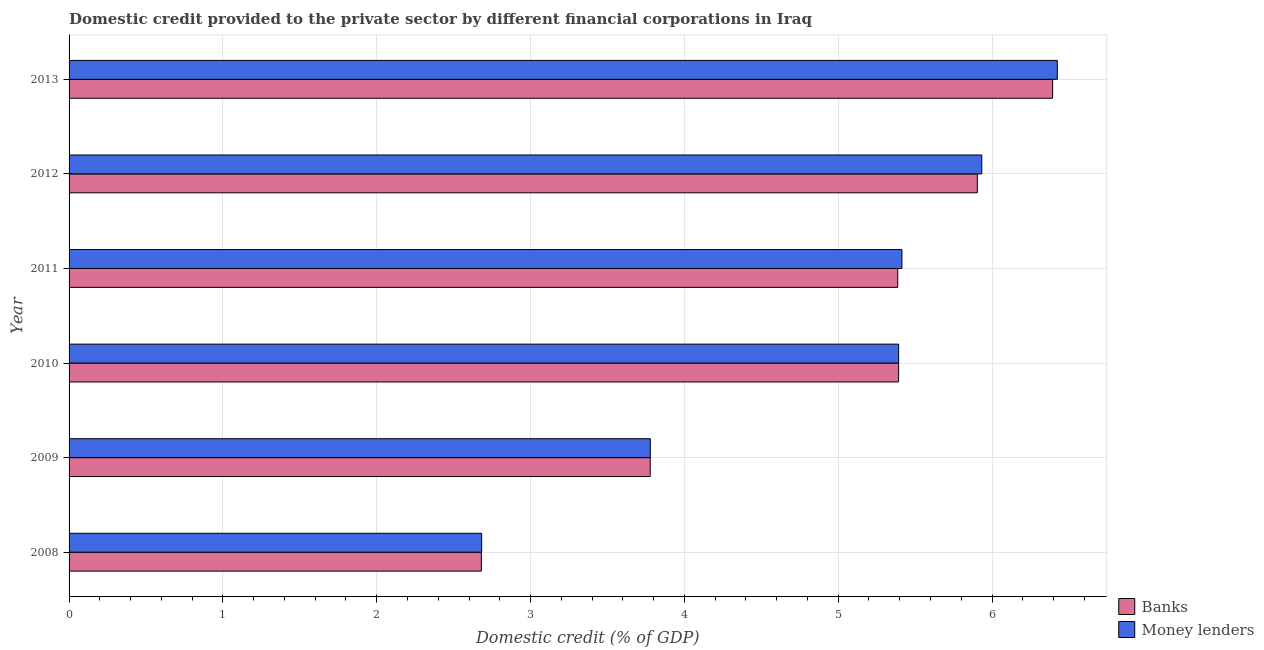How many groups of bars are there?
Make the answer very short. 6. Are the number of bars on each tick of the Y-axis equal?
Provide a succinct answer. Yes. What is the label of the 3rd group of bars from the top?
Your response must be concise. 2011. In how many cases, is the number of bars for a given year not equal to the number of legend labels?
Provide a succinct answer. 0. What is the domestic credit provided by banks in 2013?
Your response must be concise. 6.39. Across all years, what is the maximum domestic credit provided by money lenders?
Your response must be concise. 6.42. Across all years, what is the minimum domestic credit provided by money lenders?
Your answer should be compact. 2.68. What is the total domestic credit provided by banks in the graph?
Offer a terse response. 29.54. What is the difference between the domestic credit provided by banks in 2008 and that in 2011?
Offer a very short reply. -2.71. What is the difference between the domestic credit provided by banks in 2012 and the domestic credit provided by money lenders in 2011?
Provide a succinct answer. 0.49. What is the average domestic credit provided by banks per year?
Offer a very short reply. 4.92. In the year 2012, what is the difference between the domestic credit provided by money lenders and domestic credit provided by banks?
Offer a very short reply. 0.03. In how many years, is the domestic credit provided by money lenders greater than 3.2 %?
Your response must be concise. 5. What is the ratio of the domestic credit provided by money lenders in 2008 to that in 2011?
Keep it short and to the point. 0.49. Is the domestic credit provided by banks in 2008 less than that in 2010?
Offer a terse response. Yes. Is the difference between the domestic credit provided by money lenders in 2010 and 2012 greater than the difference between the domestic credit provided by banks in 2010 and 2012?
Offer a terse response. No. What is the difference between the highest and the second highest domestic credit provided by banks?
Keep it short and to the point. 0.49. What is the difference between the highest and the lowest domestic credit provided by money lenders?
Your answer should be very brief. 3.74. What does the 1st bar from the top in 2010 represents?
Provide a succinct answer. Money lenders. What does the 2nd bar from the bottom in 2010 represents?
Your answer should be compact. Money lenders. How many years are there in the graph?
Your answer should be compact. 6. What is the difference between two consecutive major ticks on the X-axis?
Ensure brevity in your answer.  1. Where does the legend appear in the graph?
Provide a succinct answer. Bottom right. How are the legend labels stacked?
Offer a very short reply. Vertical. What is the title of the graph?
Provide a short and direct response. Domestic credit provided to the private sector by different financial corporations in Iraq. Does "Resident workers" appear as one of the legend labels in the graph?
Your answer should be compact. No. What is the label or title of the X-axis?
Your response must be concise. Domestic credit (% of GDP). What is the label or title of the Y-axis?
Your response must be concise. Year. What is the Domestic credit (% of GDP) in Banks in 2008?
Offer a very short reply. 2.68. What is the Domestic credit (% of GDP) of Money lenders in 2008?
Your response must be concise. 2.68. What is the Domestic credit (% of GDP) of Banks in 2009?
Make the answer very short. 3.78. What is the Domestic credit (% of GDP) of Money lenders in 2009?
Your answer should be very brief. 3.78. What is the Domestic credit (% of GDP) of Banks in 2010?
Ensure brevity in your answer.  5.39. What is the Domestic credit (% of GDP) of Money lenders in 2010?
Your response must be concise. 5.39. What is the Domestic credit (% of GDP) in Banks in 2011?
Your response must be concise. 5.39. What is the Domestic credit (% of GDP) of Money lenders in 2011?
Give a very brief answer. 5.41. What is the Domestic credit (% of GDP) in Banks in 2012?
Ensure brevity in your answer.  5.9. What is the Domestic credit (% of GDP) of Money lenders in 2012?
Make the answer very short. 5.93. What is the Domestic credit (% of GDP) of Banks in 2013?
Offer a very short reply. 6.39. What is the Domestic credit (% of GDP) of Money lenders in 2013?
Make the answer very short. 6.42. Across all years, what is the maximum Domestic credit (% of GDP) of Banks?
Your response must be concise. 6.39. Across all years, what is the maximum Domestic credit (% of GDP) in Money lenders?
Make the answer very short. 6.42. Across all years, what is the minimum Domestic credit (% of GDP) in Banks?
Provide a short and direct response. 2.68. Across all years, what is the minimum Domestic credit (% of GDP) in Money lenders?
Your answer should be very brief. 2.68. What is the total Domestic credit (% of GDP) of Banks in the graph?
Ensure brevity in your answer.  29.54. What is the total Domestic credit (% of GDP) in Money lenders in the graph?
Provide a short and direct response. 29.63. What is the difference between the Domestic credit (% of GDP) in Banks in 2008 and that in 2009?
Provide a succinct answer. -1.1. What is the difference between the Domestic credit (% of GDP) in Money lenders in 2008 and that in 2009?
Offer a terse response. -1.1. What is the difference between the Domestic credit (% of GDP) of Banks in 2008 and that in 2010?
Provide a succinct answer. -2.71. What is the difference between the Domestic credit (% of GDP) in Money lenders in 2008 and that in 2010?
Your answer should be compact. -2.71. What is the difference between the Domestic credit (% of GDP) of Banks in 2008 and that in 2011?
Your response must be concise. -2.71. What is the difference between the Domestic credit (% of GDP) in Money lenders in 2008 and that in 2011?
Provide a succinct answer. -2.73. What is the difference between the Domestic credit (% of GDP) in Banks in 2008 and that in 2012?
Keep it short and to the point. -3.22. What is the difference between the Domestic credit (% of GDP) of Money lenders in 2008 and that in 2012?
Ensure brevity in your answer.  -3.25. What is the difference between the Domestic credit (% of GDP) of Banks in 2008 and that in 2013?
Make the answer very short. -3.71. What is the difference between the Domestic credit (% of GDP) of Money lenders in 2008 and that in 2013?
Provide a succinct answer. -3.74. What is the difference between the Domestic credit (% of GDP) of Banks in 2009 and that in 2010?
Make the answer very short. -1.61. What is the difference between the Domestic credit (% of GDP) in Money lenders in 2009 and that in 2010?
Keep it short and to the point. -1.61. What is the difference between the Domestic credit (% of GDP) of Banks in 2009 and that in 2011?
Offer a very short reply. -1.61. What is the difference between the Domestic credit (% of GDP) of Money lenders in 2009 and that in 2011?
Your response must be concise. -1.64. What is the difference between the Domestic credit (% of GDP) of Banks in 2009 and that in 2012?
Provide a short and direct response. -2.13. What is the difference between the Domestic credit (% of GDP) in Money lenders in 2009 and that in 2012?
Provide a short and direct response. -2.15. What is the difference between the Domestic credit (% of GDP) of Banks in 2009 and that in 2013?
Your answer should be very brief. -2.62. What is the difference between the Domestic credit (% of GDP) of Money lenders in 2009 and that in 2013?
Your answer should be very brief. -2.65. What is the difference between the Domestic credit (% of GDP) in Banks in 2010 and that in 2011?
Your response must be concise. 0.01. What is the difference between the Domestic credit (% of GDP) of Money lenders in 2010 and that in 2011?
Offer a very short reply. -0.02. What is the difference between the Domestic credit (% of GDP) in Banks in 2010 and that in 2012?
Provide a short and direct response. -0.51. What is the difference between the Domestic credit (% of GDP) in Money lenders in 2010 and that in 2012?
Offer a very short reply. -0.54. What is the difference between the Domestic credit (% of GDP) of Banks in 2010 and that in 2013?
Keep it short and to the point. -1. What is the difference between the Domestic credit (% of GDP) in Money lenders in 2010 and that in 2013?
Provide a short and direct response. -1.03. What is the difference between the Domestic credit (% of GDP) in Banks in 2011 and that in 2012?
Provide a short and direct response. -0.52. What is the difference between the Domestic credit (% of GDP) of Money lenders in 2011 and that in 2012?
Provide a succinct answer. -0.52. What is the difference between the Domestic credit (% of GDP) in Banks in 2011 and that in 2013?
Provide a succinct answer. -1.01. What is the difference between the Domestic credit (% of GDP) of Money lenders in 2011 and that in 2013?
Make the answer very short. -1.01. What is the difference between the Domestic credit (% of GDP) in Banks in 2012 and that in 2013?
Provide a short and direct response. -0.49. What is the difference between the Domestic credit (% of GDP) of Money lenders in 2012 and that in 2013?
Offer a very short reply. -0.49. What is the difference between the Domestic credit (% of GDP) in Banks in 2008 and the Domestic credit (% of GDP) in Money lenders in 2009?
Make the answer very short. -1.1. What is the difference between the Domestic credit (% of GDP) of Banks in 2008 and the Domestic credit (% of GDP) of Money lenders in 2010?
Keep it short and to the point. -2.71. What is the difference between the Domestic credit (% of GDP) in Banks in 2008 and the Domestic credit (% of GDP) in Money lenders in 2011?
Ensure brevity in your answer.  -2.73. What is the difference between the Domestic credit (% of GDP) of Banks in 2008 and the Domestic credit (% of GDP) of Money lenders in 2012?
Provide a short and direct response. -3.25. What is the difference between the Domestic credit (% of GDP) in Banks in 2008 and the Domestic credit (% of GDP) in Money lenders in 2013?
Your answer should be very brief. -3.74. What is the difference between the Domestic credit (% of GDP) in Banks in 2009 and the Domestic credit (% of GDP) in Money lenders in 2010?
Make the answer very short. -1.62. What is the difference between the Domestic credit (% of GDP) of Banks in 2009 and the Domestic credit (% of GDP) of Money lenders in 2011?
Give a very brief answer. -1.64. What is the difference between the Domestic credit (% of GDP) in Banks in 2009 and the Domestic credit (% of GDP) in Money lenders in 2012?
Make the answer very short. -2.16. What is the difference between the Domestic credit (% of GDP) of Banks in 2009 and the Domestic credit (% of GDP) of Money lenders in 2013?
Make the answer very short. -2.65. What is the difference between the Domestic credit (% of GDP) in Banks in 2010 and the Domestic credit (% of GDP) in Money lenders in 2011?
Provide a succinct answer. -0.02. What is the difference between the Domestic credit (% of GDP) in Banks in 2010 and the Domestic credit (% of GDP) in Money lenders in 2012?
Offer a very short reply. -0.54. What is the difference between the Domestic credit (% of GDP) of Banks in 2010 and the Domestic credit (% of GDP) of Money lenders in 2013?
Provide a succinct answer. -1.03. What is the difference between the Domestic credit (% of GDP) in Banks in 2011 and the Domestic credit (% of GDP) in Money lenders in 2012?
Your answer should be very brief. -0.55. What is the difference between the Domestic credit (% of GDP) in Banks in 2011 and the Domestic credit (% of GDP) in Money lenders in 2013?
Your answer should be very brief. -1.04. What is the difference between the Domestic credit (% of GDP) in Banks in 2012 and the Domestic credit (% of GDP) in Money lenders in 2013?
Give a very brief answer. -0.52. What is the average Domestic credit (% of GDP) in Banks per year?
Your answer should be very brief. 4.92. What is the average Domestic credit (% of GDP) in Money lenders per year?
Your answer should be compact. 4.94. In the year 2008, what is the difference between the Domestic credit (% of GDP) in Banks and Domestic credit (% of GDP) in Money lenders?
Offer a very short reply. -0. In the year 2009, what is the difference between the Domestic credit (% of GDP) of Banks and Domestic credit (% of GDP) of Money lenders?
Your answer should be compact. -0. In the year 2010, what is the difference between the Domestic credit (% of GDP) of Banks and Domestic credit (% of GDP) of Money lenders?
Offer a terse response. -0. In the year 2011, what is the difference between the Domestic credit (% of GDP) in Banks and Domestic credit (% of GDP) in Money lenders?
Your answer should be compact. -0.03. In the year 2012, what is the difference between the Domestic credit (% of GDP) in Banks and Domestic credit (% of GDP) in Money lenders?
Your answer should be very brief. -0.03. In the year 2013, what is the difference between the Domestic credit (% of GDP) of Banks and Domestic credit (% of GDP) of Money lenders?
Make the answer very short. -0.03. What is the ratio of the Domestic credit (% of GDP) in Banks in 2008 to that in 2009?
Provide a succinct answer. 0.71. What is the ratio of the Domestic credit (% of GDP) of Money lenders in 2008 to that in 2009?
Give a very brief answer. 0.71. What is the ratio of the Domestic credit (% of GDP) of Banks in 2008 to that in 2010?
Make the answer very short. 0.5. What is the ratio of the Domestic credit (% of GDP) in Money lenders in 2008 to that in 2010?
Your answer should be very brief. 0.5. What is the ratio of the Domestic credit (% of GDP) of Banks in 2008 to that in 2011?
Keep it short and to the point. 0.5. What is the ratio of the Domestic credit (% of GDP) of Money lenders in 2008 to that in 2011?
Give a very brief answer. 0.5. What is the ratio of the Domestic credit (% of GDP) in Banks in 2008 to that in 2012?
Your answer should be very brief. 0.45. What is the ratio of the Domestic credit (% of GDP) of Money lenders in 2008 to that in 2012?
Give a very brief answer. 0.45. What is the ratio of the Domestic credit (% of GDP) in Banks in 2008 to that in 2013?
Provide a succinct answer. 0.42. What is the ratio of the Domestic credit (% of GDP) in Money lenders in 2008 to that in 2013?
Ensure brevity in your answer.  0.42. What is the ratio of the Domestic credit (% of GDP) of Banks in 2009 to that in 2010?
Give a very brief answer. 0.7. What is the ratio of the Domestic credit (% of GDP) in Money lenders in 2009 to that in 2010?
Keep it short and to the point. 0.7. What is the ratio of the Domestic credit (% of GDP) in Banks in 2009 to that in 2011?
Provide a short and direct response. 0.7. What is the ratio of the Domestic credit (% of GDP) in Money lenders in 2009 to that in 2011?
Your response must be concise. 0.7. What is the ratio of the Domestic credit (% of GDP) in Banks in 2009 to that in 2012?
Provide a succinct answer. 0.64. What is the ratio of the Domestic credit (% of GDP) of Money lenders in 2009 to that in 2012?
Provide a short and direct response. 0.64. What is the ratio of the Domestic credit (% of GDP) in Banks in 2009 to that in 2013?
Keep it short and to the point. 0.59. What is the ratio of the Domestic credit (% of GDP) of Money lenders in 2009 to that in 2013?
Keep it short and to the point. 0.59. What is the ratio of the Domestic credit (% of GDP) of Banks in 2010 to that in 2011?
Ensure brevity in your answer.  1. What is the ratio of the Domestic credit (% of GDP) in Money lenders in 2010 to that in 2011?
Provide a succinct answer. 1. What is the ratio of the Domestic credit (% of GDP) of Banks in 2010 to that in 2012?
Offer a terse response. 0.91. What is the ratio of the Domestic credit (% of GDP) in Money lenders in 2010 to that in 2012?
Keep it short and to the point. 0.91. What is the ratio of the Domestic credit (% of GDP) of Banks in 2010 to that in 2013?
Provide a succinct answer. 0.84. What is the ratio of the Domestic credit (% of GDP) in Money lenders in 2010 to that in 2013?
Provide a short and direct response. 0.84. What is the ratio of the Domestic credit (% of GDP) in Banks in 2011 to that in 2012?
Your response must be concise. 0.91. What is the ratio of the Domestic credit (% of GDP) in Money lenders in 2011 to that in 2012?
Give a very brief answer. 0.91. What is the ratio of the Domestic credit (% of GDP) of Banks in 2011 to that in 2013?
Give a very brief answer. 0.84. What is the ratio of the Domestic credit (% of GDP) in Money lenders in 2011 to that in 2013?
Your response must be concise. 0.84. What is the ratio of the Domestic credit (% of GDP) in Banks in 2012 to that in 2013?
Your answer should be very brief. 0.92. What is the ratio of the Domestic credit (% of GDP) of Money lenders in 2012 to that in 2013?
Your answer should be very brief. 0.92. What is the difference between the highest and the second highest Domestic credit (% of GDP) in Banks?
Provide a succinct answer. 0.49. What is the difference between the highest and the second highest Domestic credit (% of GDP) of Money lenders?
Keep it short and to the point. 0.49. What is the difference between the highest and the lowest Domestic credit (% of GDP) in Banks?
Make the answer very short. 3.71. What is the difference between the highest and the lowest Domestic credit (% of GDP) of Money lenders?
Provide a succinct answer. 3.74. 